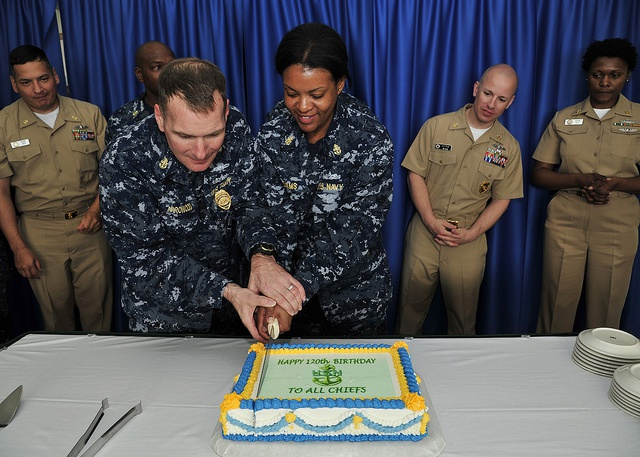Describe the objects in this image and their specific colors. I can see dining table in navy, darkgray, gray, black, and lightgray tones, people in navy, black, and gray tones, people in navy, black, gray, and brown tones, people in navy, black, gray, and brown tones, and people in navy, black, gray, and maroon tones in this image. 